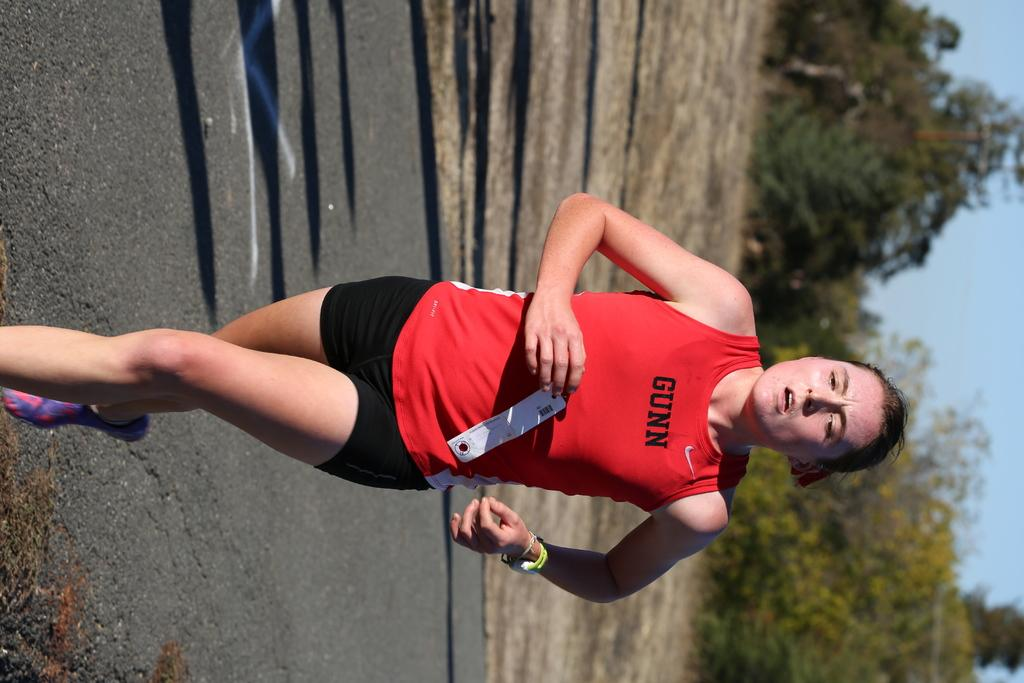Provide a one-sentence caption for the provided image. The runner is wearing a red tank top that says "gunn" on it. 